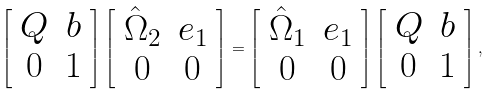<formula> <loc_0><loc_0><loc_500><loc_500>\left [ \begin{array} { c c } Q & { b } \\ { 0 } & 1 \end{array} \right ] \left [ \begin{array} { c c } \hat { \Omega } _ { 2 } & { e } _ { 1 } \\ { 0 } & 0 \end{array} \right ] = \left [ \begin{array} { c c } \hat { \Omega } _ { 1 } & { e } _ { 1 } \\ { 0 } & 0 \end{array} \right ] \left [ \begin{array} { c c } Q & { b } \\ { 0 } & 1 \end{array} \right ] ,</formula> 